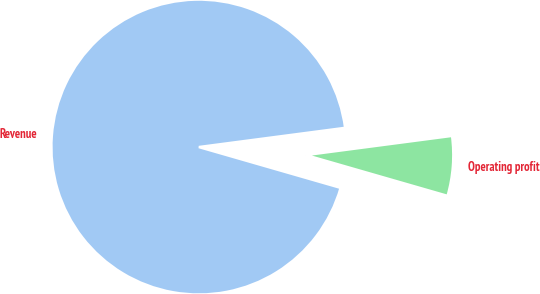<chart> <loc_0><loc_0><loc_500><loc_500><pie_chart><fcel>Revenue<fcel>Operating profit<nl><fcel>93.46%<fcel>6.54%<nl></chart> 